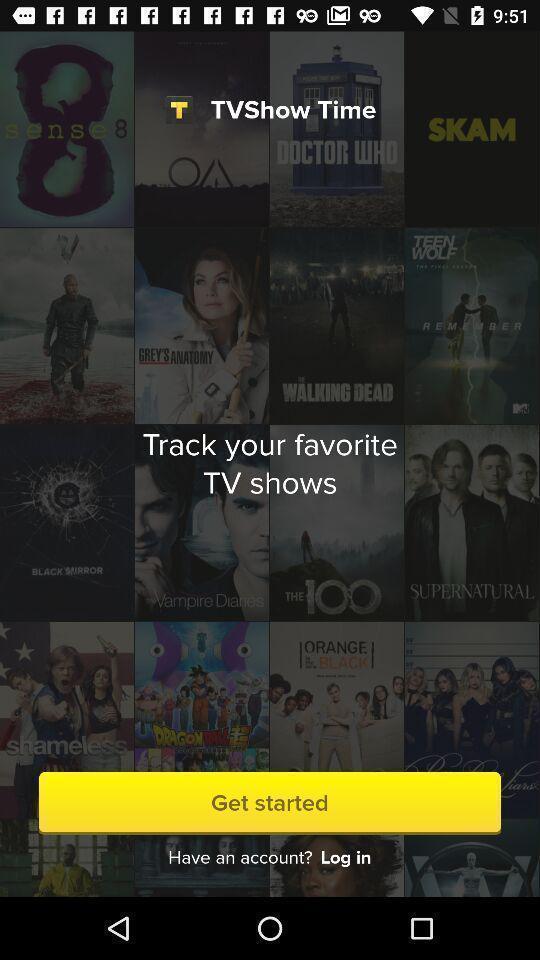Provide a description of this screenshot. Welcome page of a tv shows tracking app. 